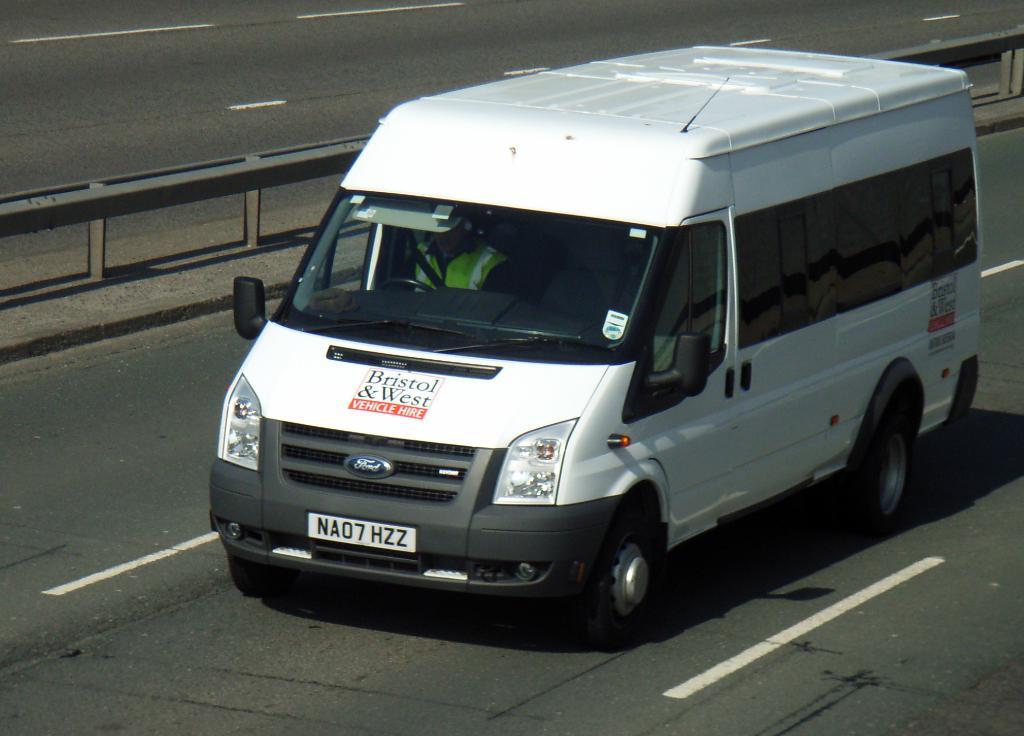What is the license plate?
Keep it short and to the point. Na07 hzz. The vans company name is?
Give a very brief answer. Bristol & west. 